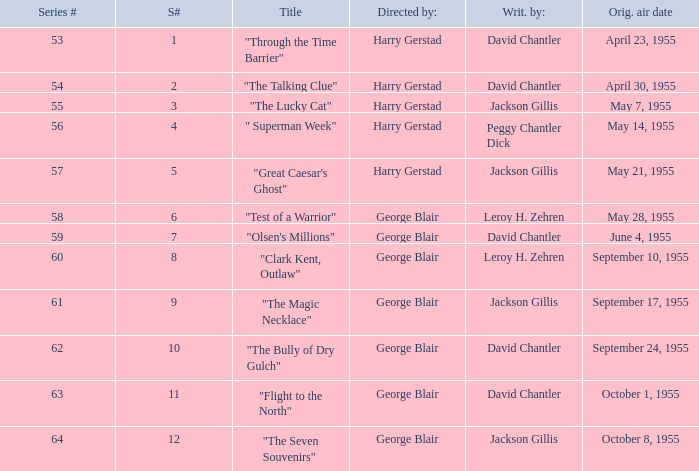Which Season originally aired on September 17, 1955 9.0. 